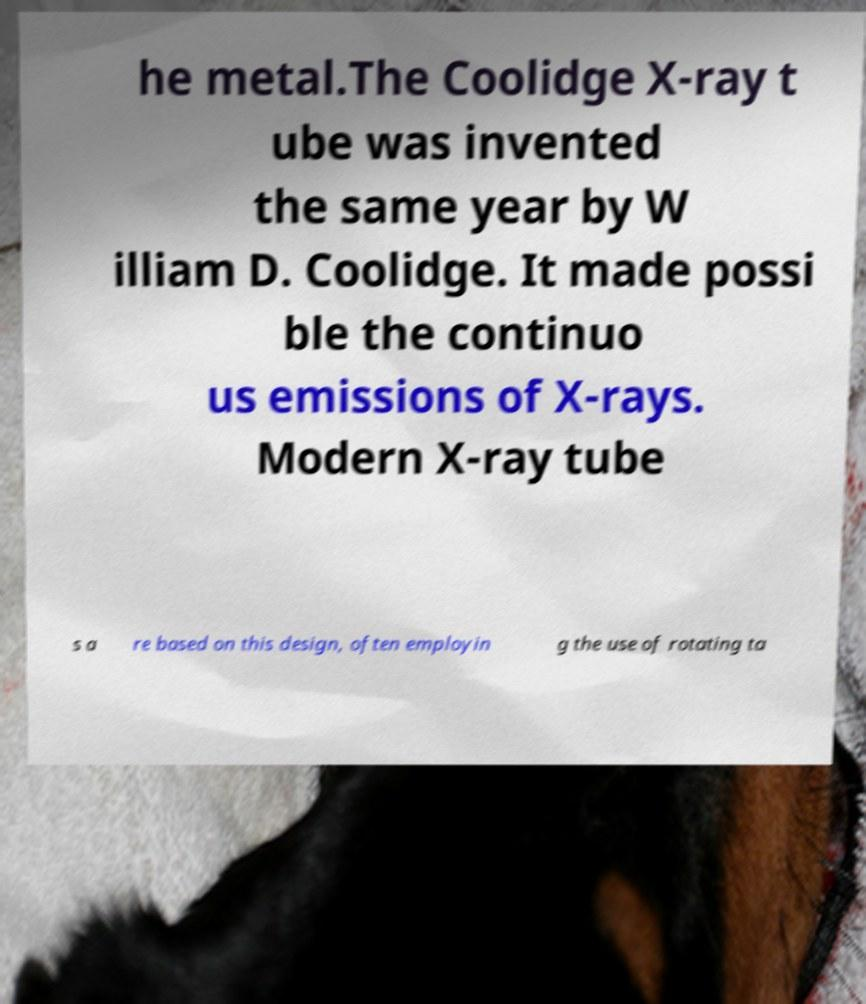There's text embedded in this image that I need extracted. Can you transcribe it verbatim? he metal.The Coolidge X-ray t ube was invented the same year by W illiam D. Coolidge. It made possi ble the continuo us emissions of X-rays. Modern X-ray tube s a re based on this design, often employin g the use of rotating ta 